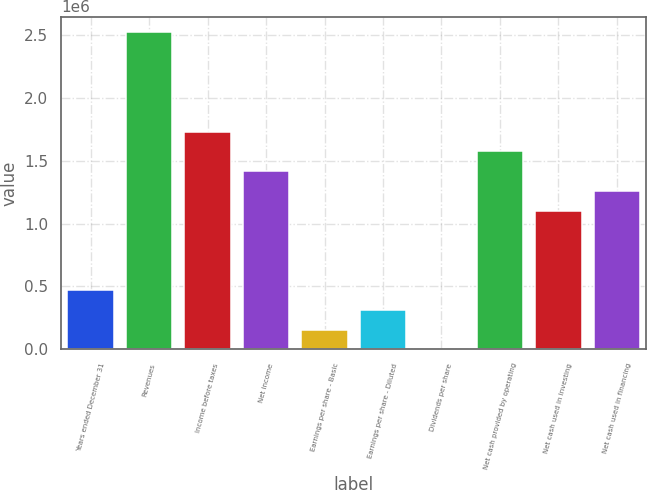<chart> <loc_0><loc_0><loc_500><loc_500><bar_chart><fcel>Years ended December 31<fcel>Revenues<fcel>Income before taxes<fcel>Net income<fcel>Earnings per share - Basic<fcel>Earnings per share - Diluted<fcel>Dividends per share<fcel>Net cash provided by operating<fcel>Net cash used in investing<fcel>Net cash used in financing<nl><fcel>472043<fcel>2.51756e+06<fcel>1.73082e+06<fcel>1.41613e+06<fcel>157348<fcel>314696<fcel>0.33<fcel>1.57348e+06<fcel>1.10143e+06<fcel>1.25878e+06<nl></chart> 